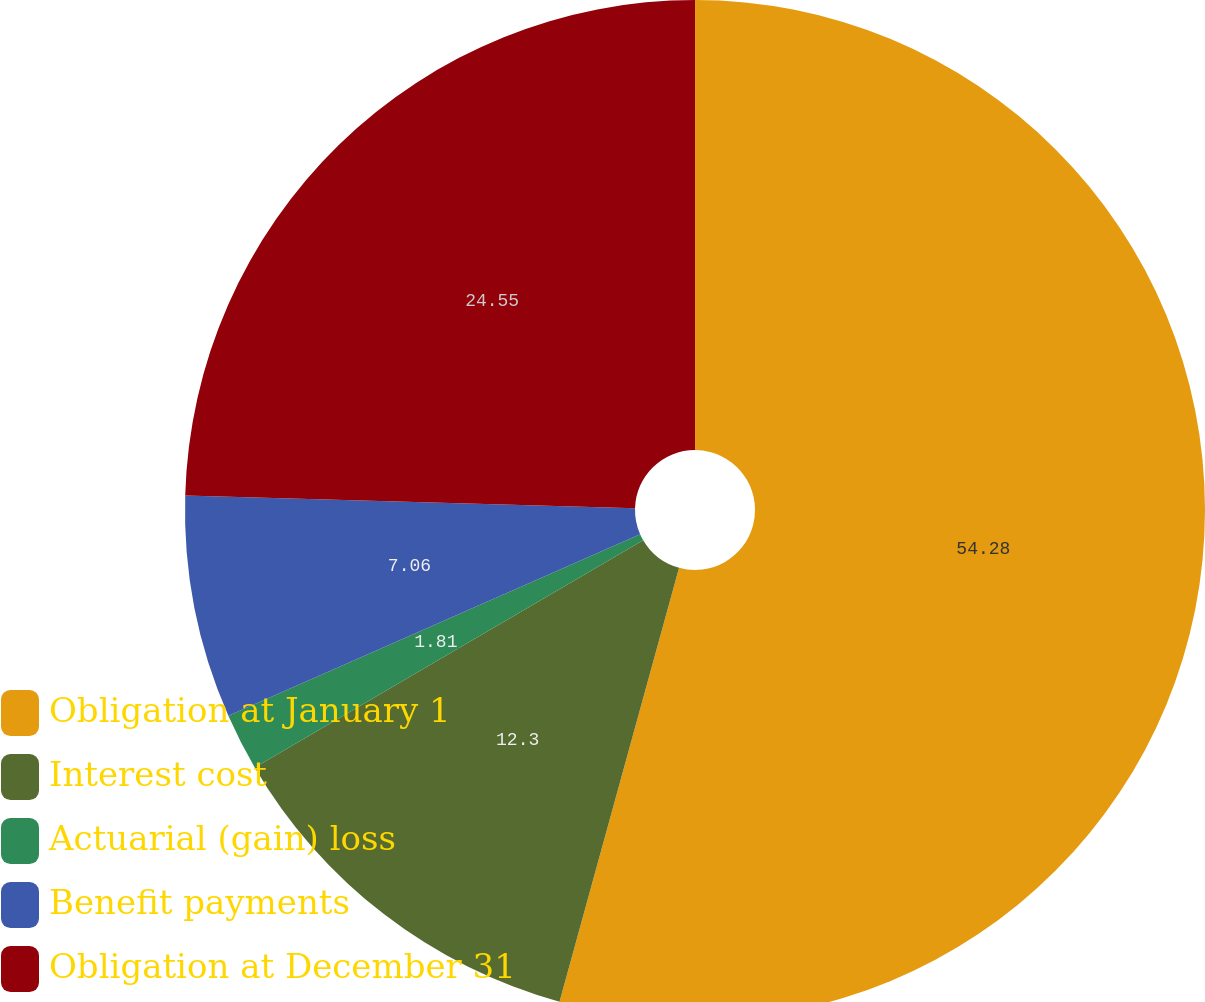Convert chart. <chart><loc_0><loc_0><loc_500><loc_500><pie_chart><fcel>Obligation at January 1<fcel>Interest cost<fcel>Actuarial (gain) loss<fcel>Benefit payments<fcel>Obligation at December 31<nl><fcel>54.28%<fcel>12.3%<fcel>1.81%<fcel>7.06%<fcel>24.55%<nl></chart> 